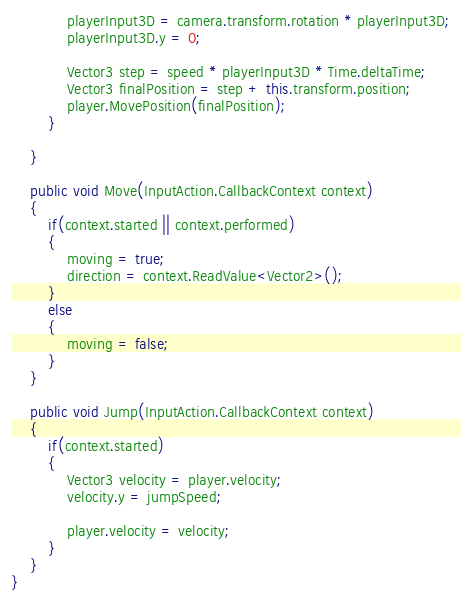Convert code to text. <code><loc_0><loc_0><loc_500><loc_500><_C#_>
            playerInput3D = camera.transform.rotation * playerInput3D;
            playerInput3D.y = 0;

            Vector3 step = speed * playerInput3D * Time.deltaTime;
            Vector3 finalPosition = step + this.transform.position;
            player.MovePosition(finalPosition);
        }
        
    }

    public void Move(InputAction.CallbackContext context)
    {
        if(context.started || context.performed)
        {
            moving = true;
            direction = context.ReadValue<Vector2>();
        }
        else
        {
            moving = false;
        }
    }

    public void Jump(InputAction.CallbackContext context)
    {
        if(context.started)
        {
            Vector3 velocity = player.velocity;
            velocity.y = jumpSpeed;

            player.velocity = velocity;
        }
    }
}
</code> 